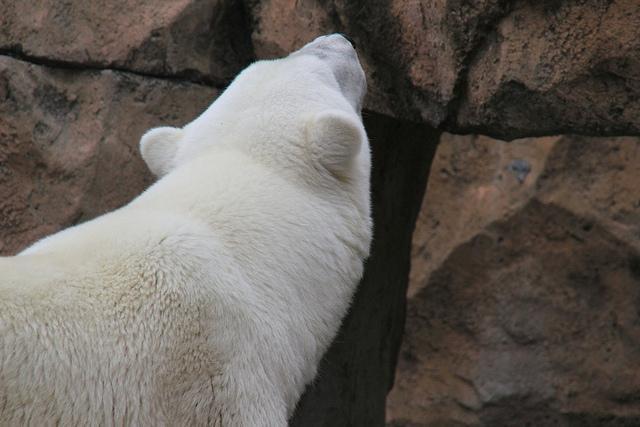How many orange lights are on the back of the bus?
Give a very brief answer. 0. 